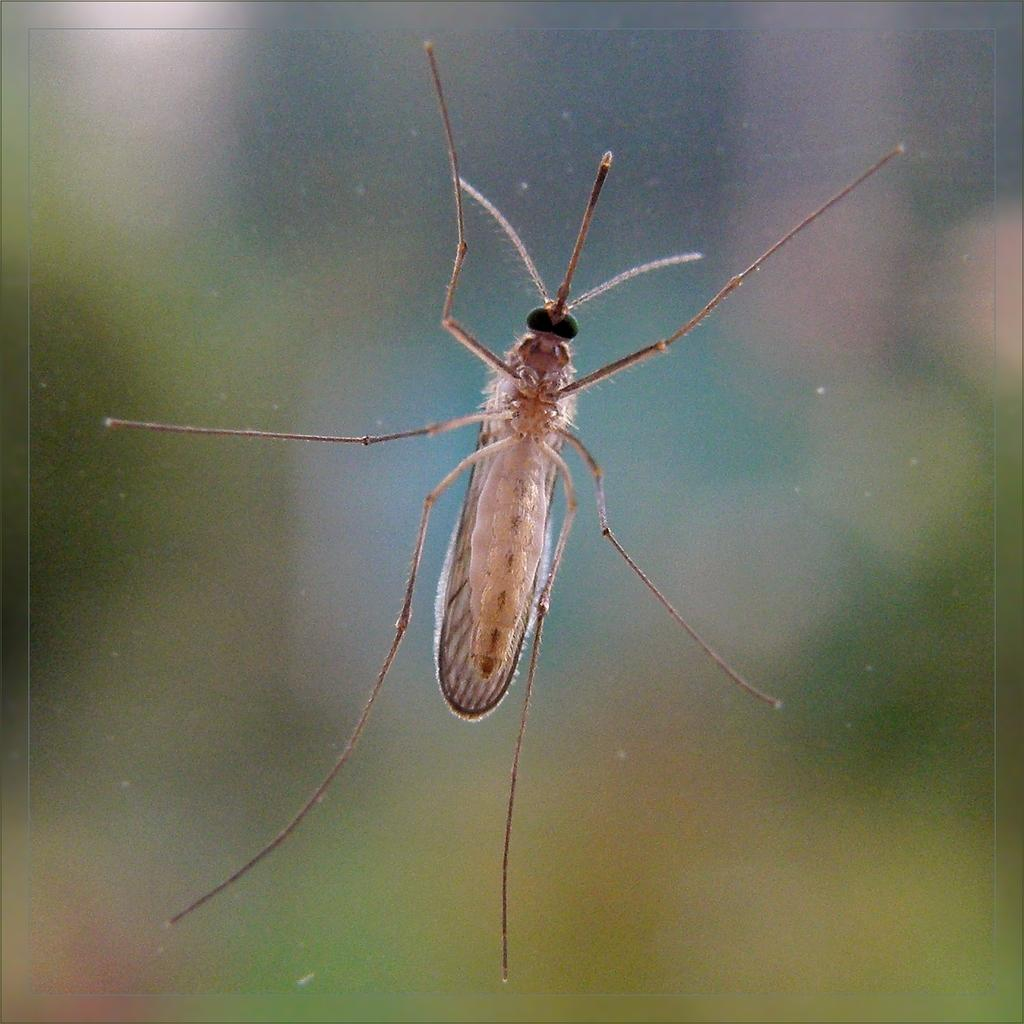What is the main subject in the center of the image? There is a mosquito on the glass in the center of the image. Can you describe the background of the image? The background of the image is blurred. What type of advertisement can be seen on the glass in the image? There is no advertisement present on the glass in the image; it only features a mosquito. What color of ink is used to draw the mosquito on the glass in the image? There is no indication that the mosquito is drawn or painted on the glass, and therefore no ink color can be determined. 